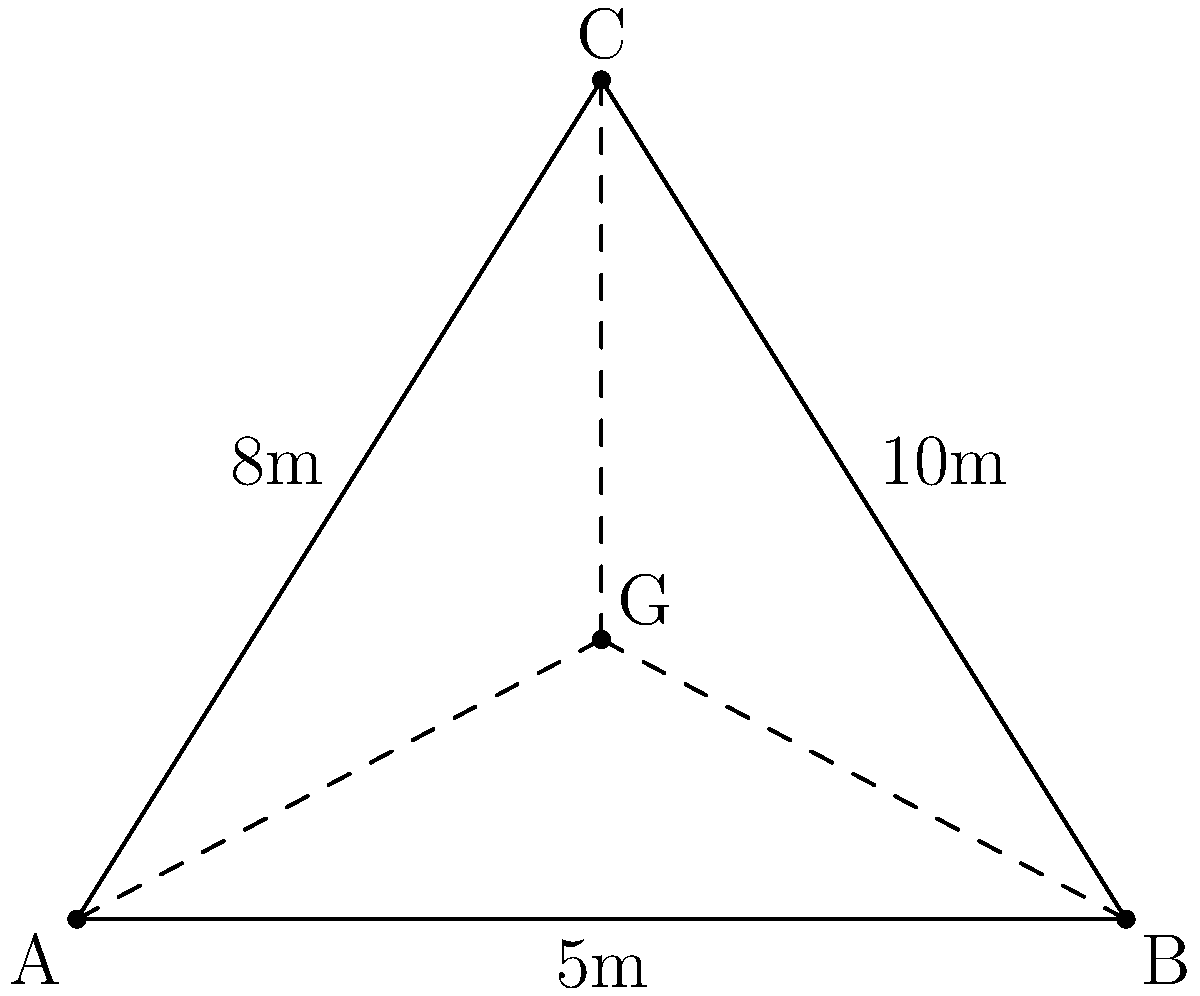A new triangular cargo hold is being considered for our next-generation aircraft. The hold's base is 10 meters wide, and its height is 8 meters. To optimize fuel efficiency and aircraft stability, we need to ensure that cargo is loaded around the center of gravity. If the center of gravity is located at the centroid of the triangular hold, how far is it from the base of the triangle? To solve this problem, we'll follow these steps:

1) In a triangle, the centroid (center of gravity) is located at the intersection of the medians. Each median divides the opposite side into two equal parts.

2) The centroid divides each median in a 2:1 ratio, with the longer segment closer to the vertex.

3) We can use the formula for the y-coordinate of the centroid in a triangle:

   $$y_G = \frac{y_A + y_B + y_C}{3}$$

   Where $(x_G, y_G)$ are the coordinates of the centroid G, and A, B, C are the vertices of the triangle.

4) In our case, if we place the triangle in a coordinate system with the base on the x-axis:
   A(0,0), B(10,0), C(5,8)

5) Applying the formula:

   $$y_G = \frac{0 + 0 + 8}{3} = \frac{8}{3} \approx 2.67$$

6) Therefore, the center of gravity is approximately 2.67 meters above the base of the triangle.
Answer: 2.67 meters 